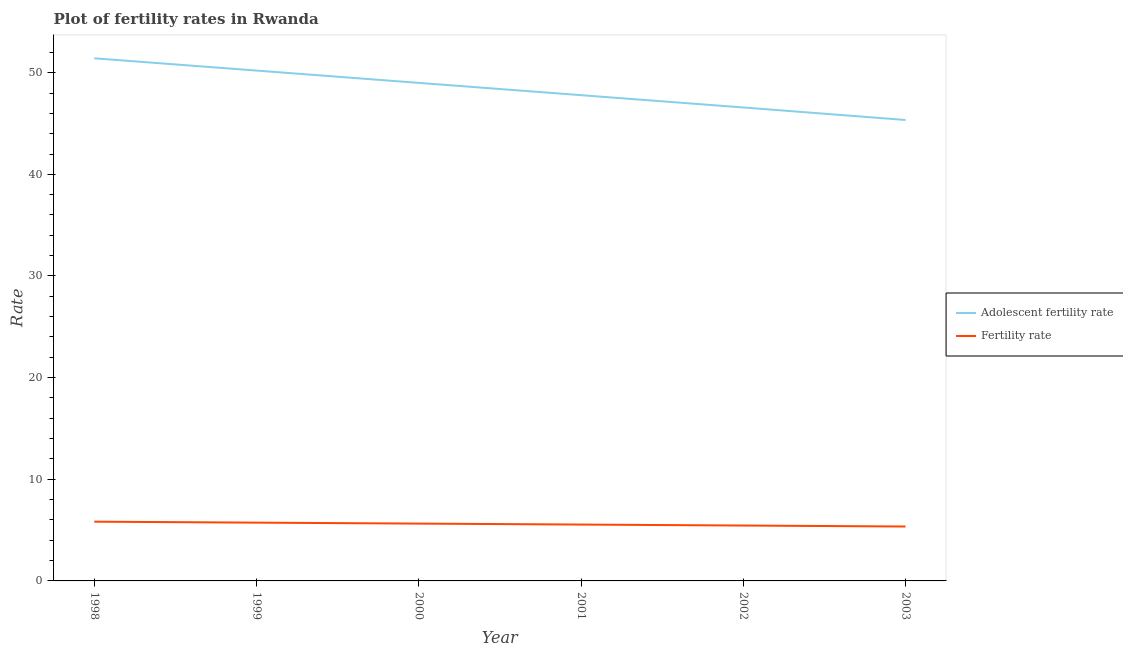Is the number of lines equal to the number of legend labels?
Your response must be concise. Yes. What is the adolescent fertility rate in 1999?
Provide a short and direct response. 50.21. Across all years, what is the maximum adolescent fertility rate?
Provide a short and direct response. 51.42. Across all years, what is the minimum adolescent fertility rate?
Keep it short and to the point. 45.35. In which year was the fertility rate minimum?
Offer a terse response. 2003. What is the total adolescent fertility rate in the graph?
Your answer should be compact. 290.34. What is the difference between the fertility rate in 1998 and that in 2001?
Offer a very short reply. 0.28. What is the difference between the adolescent fertility rate in 2002 and the fertility rate in 2001?
Offer a very short reply. 41.03. What is the average fertility rate per year?
Offer a terse response. 5.59. In the year 1999, what is the difference between the adolescent fertility rate and fertility rate?
Ensure brevity in your answer.  44.47. In how many years, is the adolescent fertility rate greater than 8?
Ensure brevity in your answer.  6. What is the ratio of the adolescent fertility rate in 2000 to that in 2001?
Provide a succinct answer. 1.03. Is the difference between the fertility rate in 1999 and 2003 greater than the difference between the adolescent fertility rate in 1999 and 2003?
Your response must be concise. No. What is the difference between the highest and the second highest adolescent fertility rate?
Keep it short and to the point. 1.21. What is the difference between the highest and the lowest fertility rate?
Your response must be concise. 0.48. Does the adolescent fertility rate monotonically increase over the years?
Give a very brief answer. No. Is the fertility rate strictly greater than the adolescent fertility rate over the years?
Give a very brief answer. No. Is the fertility rate strictly less than the adolescent fertility rate over the years?
Give a very brief answer. Yes. How many lines are there?
Make the answer very short. 2. What is the difference between two consecutive major ticks on the Y-axis?
Provide a short and direct response. 10. Are the values on the major ticks of Y-axis written in scientific E-notation?
Offer a very short reply. No. Does the graph contain any zero values?
Provide a short and direct response. No. Does the graph contain grids?
Give a very brief answer. No. Where does the legend appear in the graph?
Your response must be concise. Center right. What is the title of the graph?
Ensure brevity in your answer.  Plot of fertility rates in Rwanda. What is the label or title of the Y-axis?
Provide a succinct answer. Rate. What is the Rate of Adolescent fertility rate in 1998?
Make the answer very short. 51.42. What is the Rate of Fertility rate in 1998?
Your answer should be compact. 5.83. What is the Rate of Adolescent fertility rate in 1999?
Provide a short and direct response. 50.21. What is the Rate in Fertility rate in 1999?
Make the answer very short. 5.73. What is the Rate in Adolescent fertility rate in 2000?
Offer a terse response. 49. What is the Rate in Fertility rate in 2000?
Your answer should be compact. 5.64. What is the Rate of Adolescent fertility rate in 2001?
Provide a succinct answer. 47.79. What is the Rate in Fertility rate in 2001?
Give a very brief answer. 5.54. What is the Rate of Adolescent fertility rate in 2002?
Make the answer very short. 46.58. What is the Rate of Fertility rate in 2002?
Offer a very short reply. 5.45. What is the Rate in Adolescent fertility rate in 2003?
Your response must be concise. 45.35. What is the Rate of Fertility rate in 2003?
Keep it short and to the point. 5.35. Across all years, what is the maximum Rate in Adolescent fertility rate?
Your answer should be very brief. 51.42. Across all years, what is the maximum Rate in Fertility rate?
Make the answer very short. 5.83. Across all years, what is the minimum Rate of Adolescent fertility rate?
Give a very brief answer. 45.35. Across all years, what is the minimum Rate in Fertility rate?
Make the answer very short. 5.35. What is the total Rate of Adolescent fertility rate in the graph?
Offer a very short reply. 290.34. What is the total Rate in Fertility rate in the graph?
Your response must be concise. 33.55. What is the difference between the Rate of Adolescent fertility rate in 1998 and that in 1999?
Your response must be concise. 1.21. What is the difference between the Rate in Fertility rate in 1998 and that in 1999?
Your response must be concise. 0.1. What is the difference between the Rate in Adolescent fertility rate in 1998 and that in 2000?
Provide a short and direct response. 2.42. What is the difference between the Rate of Fertility rate in 1998 and that in 2000?
Your response must be concise. 0.19. What is the difference between the Rate in Adolescent fertility rate in 1998 and that in 2001?
Ensure brevity in your answer.  3.63. What is the difference between the Rate of Fertility rate in 1998 and that in 2001?
Ensure brevity in your answer.  0.28. What is the difference between the Rate of Adolescent fertility rate in 1998 and that in 2002?
Keep it short and to the point. 4.84. What is the difference between the Rate in Fertility rate in 1998 and that in 2002?
Your answer should be very brief. 0.38. What is the difference between the Rate in Adolescent fertility rate in 1998 and that in 2003?
Your response must be concise. 6.07. What is the difference between the Rate of Fertility rate in 1998 and that in 2003?
Provide a short and direct response. 0.48. What is the difference between the Rate of Adolescent fertility rate in 1999 and that in 2000?
Offer a very short reply. 1.21. What is the difference between the Rate of Fertility rate in 1999 and that in 2000?
Your response must be concise. 0.09. What is the difference between the Rate in Adolescent fertility rate in 1999 and that in 2001?
Give a very brief answer. 2.42. What is the difference between the Rate in Fertility rate in 1999 and that in 2001?
Offer a very short reply. 0.19. What is the difference between the Rate of Adolescent fertility rate in 1999 and that in 2002?
Your answer should be very brief. 3.63. What is the difference between the Rate in Fertility rate in 1999 and that in 2002?
Provide a succinct answer. 0.28. What is the difference between the Rate in Adolescent fertility rate in 1999 and that in 2003?
Offer a very short reply. 4.86. What is the difference between the Rate of Fertility rate in 1999 and that in 2003?
Offer a very short reply. 0.38. What is the difference between the Rate in Adolescent fertility rate in 2000 and that in 2001?
Ensure brevity in your answer.  1.21. What is the difference between the Rate of Fertility rate in 2000 and that in 2001?
Your answer should be very brief. 0.1. What is the difference between the Rate in Adolescent fertility rate in 2000 and that in 2002?
Offer a terse response. 2.42. What is the difference between the Rate in Fertility rate in 2000 and that in 2002?
Ensure brevity in your answer.  0.19. What is the difference between the Rate of Adolescent fertility rate in 2000 and that in 2003?
Ensure brevity in your answer.  3.65. What is the difference between the Rate of Fertility rate in 2000 and that in 2003?
Make the answer very short. 0.29. What is the difference between the Rate in Adolescent fertility rate in 2001 and that in 2002?
Offer a terse response. 1.21. What is the difference between the Rate in Fertility rate in 2001 and that in 2002?
Make the answer very short. 0.1. What is the difference between the Rate of Adolescent fertility rate in 2001 and that in 2003?
Provide a short and direct response. 2.44. What is the difference between the Rate in Fertility rate in 2001 and that in 2003?
Provide a succinct answer. 0.19. What is the difference between the Rate in Adolescent fertility rate in 2002 and that in 2003?
Make the answer very short. 1.23. What is the difference between the Rate of Fertility rate in 2002 and that in 2003?
Your answer should be very brief. 0.1. What is the difference between the Rate of Adolescent fertility rate in 1998 and the Rate of Fertility rate in 1999?
Provide a short and direct response. 45.68. What is the difference between the Rate in Adolescent fertility rate in 1998 and the Rate in Fertility rate in 2000?
Provide a short and direct response. 45.78. What is the difference between the Rate of Adolescent fertility rate in 1998 and the Rate of Fertility rate in 2001?
Your response must be concise. 45.87. What is the difference between the Rate of Adolescent fertility rate in 1998 and the Rate of Fertility rate in 2002?
Provide a short and direct response. 45.97. What is the difference between the Rate in Adolescent fertility rate in 1998 and the Rate in Fertility rate in 2003?
Offer a terse response. 46.06. What is the difference between the Rate of Adolescent fertility rate in 1999 and the Rate of Fertility rate in 2000?
Ensure brevity in your answer.  44.57. What is the difference between the Rate of Adolescent fertility rate in 1999 and the Rate of Fertility rate in 2001?
Give a very brief answer. 44.66. What is the difference between the Rate in Adolescent fertility rate in 1999 and the Rate in Fertility rate in 2002?
Your response must be concise. 44.76. What is the difference between the Rate in Adolescent fertility rate in 1999 and the Rate in Fertility rate in 2003?
Give a very brief answer. 44.86. What is the difference between the Rate in Adolescent fertility rate in 2000 and the Rate in Fertility rate in 2001?
Ensure brevity in your answer.  43.45. What is the difference between the Rate in Adolescent fertility rate in 2000 and the Rate in Fertility rate in 2002?
Give a very brief answer. 43.55. What is the difference between the Rate in Adolescent fertility rate in 2000 and the Rate in Fertility rate in 2003?
Make the answer very short. 43.65. What is the difference between the Rate in Adolescent fertility rate in 2001 and the Rate in Fertility rate in 2002?
Make the answer very short. 42.34. What is the difference between the Rate in Adolescent fertility rate in 2001 and the Rate in Fertility rate in 2003?
Your response must be concise. 42.44. What is the difference between the Rate of Adolescent fertility rate in 2002 and the Rate of Fertility rate in 2003?
Provide a short and direct response. 41.23. What is the average Rate in Adolescent fertility rate per year?
Offer a terse response. 48.39. What is the average Rate of Fertility rate per year?
Your response must be concise. 5.59. In the year 1998, what is the difference between the Rate in Adolescent fertility rate and Rate in Fertility rate?
Keep it short and to the point. 45.59. In the year 1999, what is the difference between the Rate in Adolescent fertility rate and Rate in Fertility rate?
Keep it short and to the point. 44.47. In the year 2000, what is the difference between the Rate of Adolescent fertility rate and Rate of Fertility rate?
Offer a terse response. 43.36. In the year 2001, what is the difference between the Rate in Adolescent fertility rate and Rate in Fertility rate?
Provide a succinct answer. 42.24. In the year 2002, what is the difference between the Rate of Adolescent fertility rate and Rate of Fertility rate?
Keep it short and to the point. 41.13. In the year 2003, what is the difference between the Rate in Adolescent fertility rate and Rate in Fertility rate?
Ensure brevity in your answer.  39.99. What is the ratio of the Rate of Adolescent fertility rate in 1998 to that in 1999?
Offer a very short reply. 1.02. What is the ratio of the Rate in Fertility rate in 1998 to that in 1999?
Give a very brief answer. 1.02. What is the ratio of the Rate in Adolescent fertility rate in 1998 to that in 2000?
Keep it short and to the point. 1.05. What is the ratio of the Rate in Fertility rate in 1998 to that in 2000?
Your response must be concise. 1.03. What is the ratio of the Rate in Adolescent fertility rate in 1998 to that in 2001?
Offer a terse response. 1.08. What is the ratio of the Rate in Fertility rate in 1998 to that in 2001?
Your response must be concise. 1.05. What is the ratio of the Rate of Adolescent fertility rate in 1998 to that in 2002?
Offer a very short reply. 1.1. What is the ratio of the Rate of Fertility rate in 1998 to that in 2002?
Give a very brief answer. 1.07. What is the ratio of the Rate in Adolescent fertility rate in 1998 to that in 2003?
Provide a succinct answer. 1.13. What is the ratio of the Rate of Fertility rate in 1998 to that in 2003?
Make the answer very short. 1.09. What is the ratio of the Rate in Adolescent fertility rate in 1999 to that in 2000?
Keep it short and to the point. 1.02. What is the ratio of the Rate of Fertility rate in 1999 to that in 2000?
Provide a short and direct response. 1.02. What is the ratio of the Rate of Adolescent fertility rate in 1999 to that in 2001?
Offer a very short reply. 1.05. What is the ratio of the Rate in Fertility rate in 1999 to that in 2001?
Make the answer very short. 1.03. What is the ratio of the Rate of Adolescent fertility rate in 1999 to that in 2002?
Provide a short and direct response. 1.08. What is the ratio of the Rate in Fertility rate in 1999 to that in 2002?
Make the answer very short. 1.05. What is the ratio of the Rate of Adolescent fertility rate in 1999 to that in 2003?
Offer a terse response. 1.11. What is the ratio of the Rate in Fertility rate in 1999 to that in 2003?
Provide a succinct answer. 1.07. What is the ratio of the Rate in Adolescent fertility rate in 2000 to that in 2001?
Offer a terse response. 1.03. What is the ratio of the Rate in Fertility rate in 2000 to that in 2001?
Make the answer very short. 1.02. What is the ratio of the Rate of Adolescent fertility rate in 2000 to that in 2002?
Make the answer very short. 1.05. What is the ratio of the Rate of Fertility rate in 2000 to that in 2002?
Your response must be concise. 1.04. What is the ratio of the Rate of Adolescent fertility rate in 2000 to that in 2003?
Provide a succinct answer. 1.08. What is the ratio of the Rate in Fertility rate in 2000 to that in 2003?
Make the answer very short. 1.05. What is the ratio of the Rate in Adolescent fertility rate in 2001 to that in 2002?
Your answer should be compact. 1.03. What is the ratio of the Rate of Fertility rate in 2001 to that in 2002?
Your answer should be very brief. 1.02. What is the ratio of the Rate in Adolescent fertility rate in 2001 to that in 2003?
Give a very brief answer. 1.05. What is the ratio of the Rate of Fertility rate in 2001 to that in 2003?
Keep it short and to the point. 1.04. What is the ratio of the Rate in Adolescent fertility rate in 2002 to that in 2003?
Your answer should be compact. 1.03. What is the ratio of the Rate of Fertility rate in 2002 to that in 2003?
Your answer should be compact. 1.02. What is the difference between the highest and the second highest Rate in Adolescent fertility rate?
Provide a succinct answer. 1.21. What is the difference between the highest and the second highest Rate in Fertility rate?
Make the answer very short. 0.1. What is the difference between the highest and the lowest Rate of Adolescent fertility rate?
Offer a terse response. 6.07. What is the difference between the highest and the lowest Rate in Fertility rate?
Offer a very short reply. 0.48. 